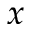<formula> <loc_0><loc_0><loc_500><loc_500>x</formula> 